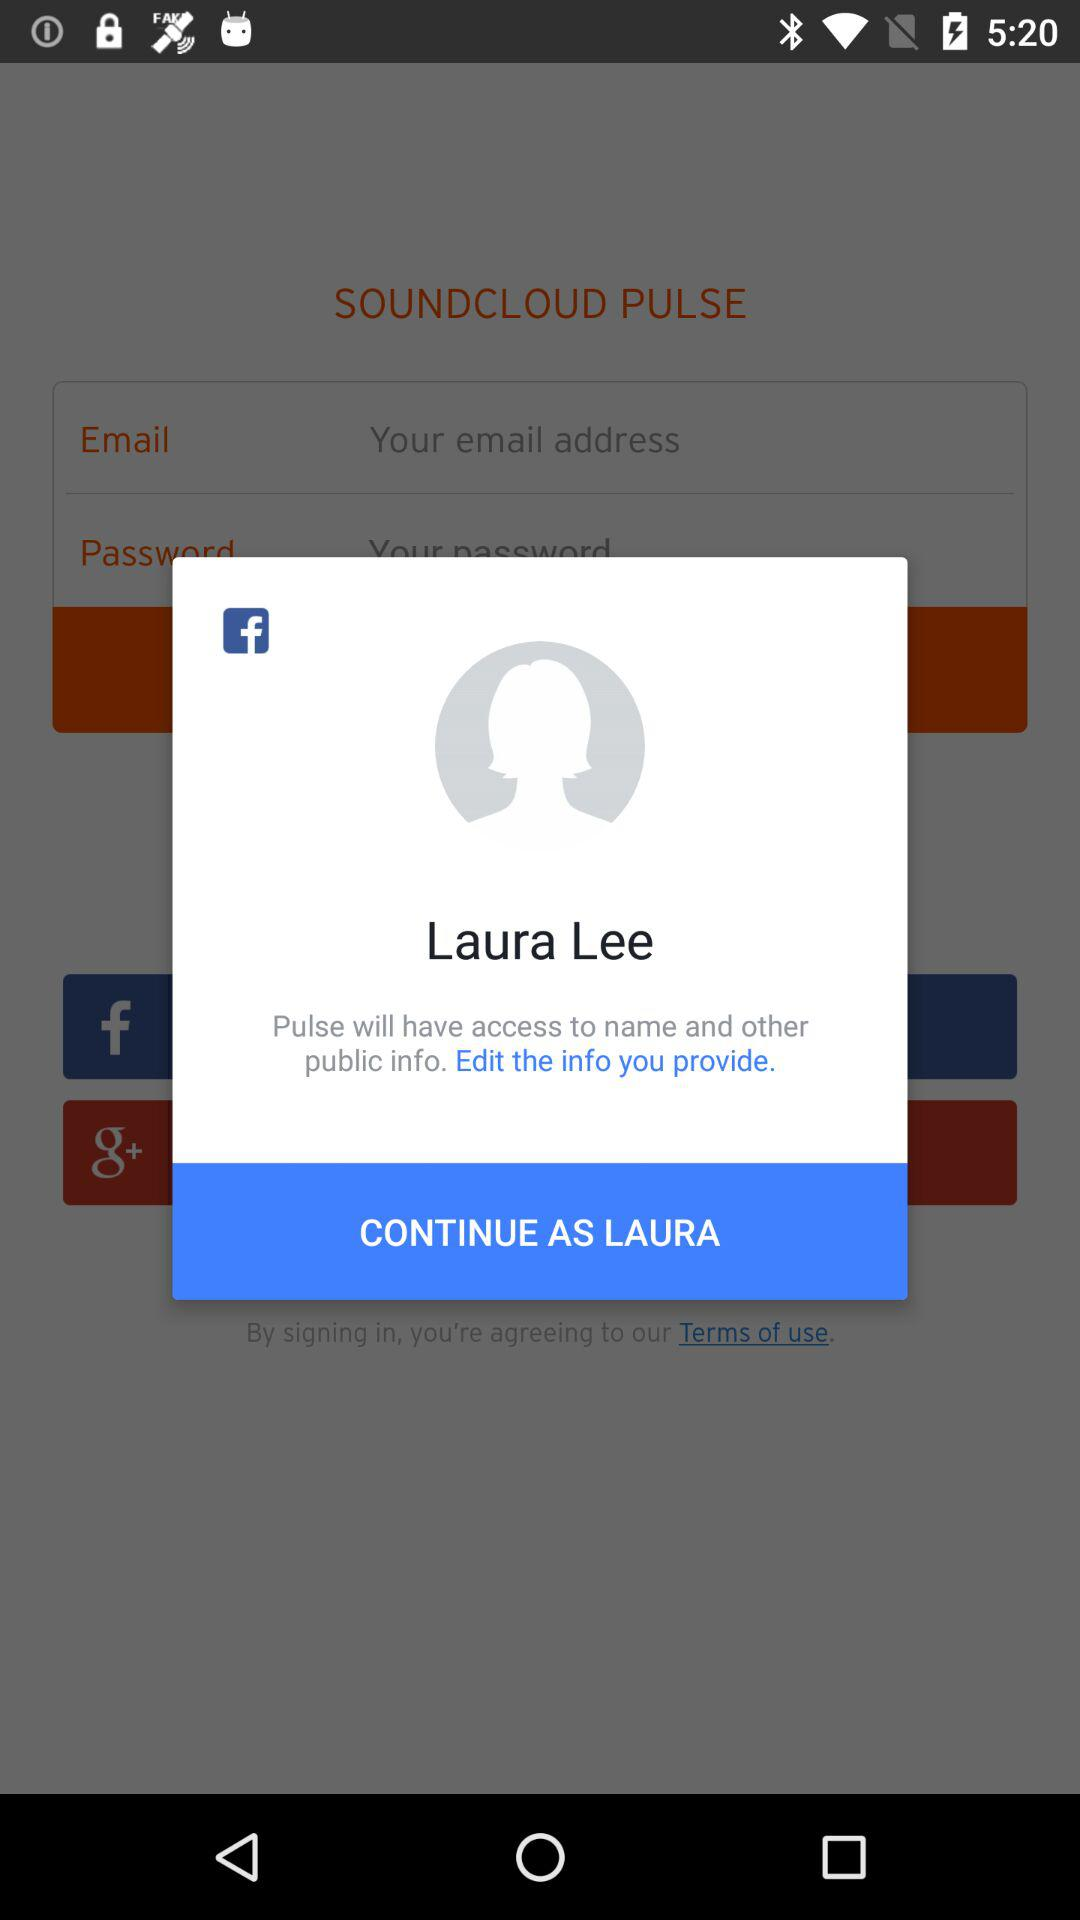What is the name of the user? The name of the user is Laura Lee. 